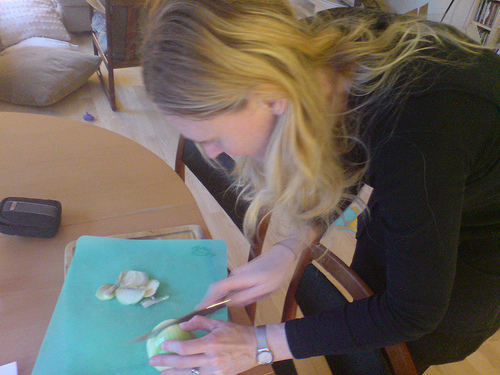<image>
Is the knife in the onion? Yes. The knife is contained within or inside the onion, showing a containment relationship. Is there a woman on the knife? No. The woman is not positioned on the knife. They may be near each other, but the woman is not supported by or resting on top of the knife. 